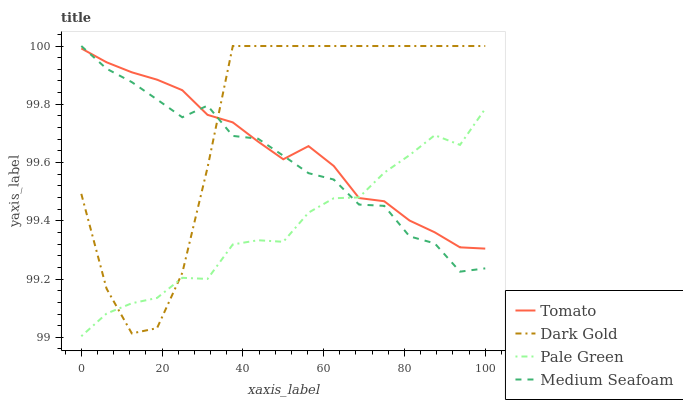Does Pale Green have the minimum area under the curve?
Answer yes or no. Yes. Does Dark Gold have the maximum area under the curve?
Answer yes or no. Yes. Does Medium Seafoam have the minimum area under the curve?
Answer yes or no. No. Does Medium Seafoam have the maximum area under the curve?
Answer yes or no. No. Is Tomato the smoothest?
Answer yes or no. Yes. Is Dark Gold the roughest?
Answer yes or no. Yes. Is Pale Green the smoothest?
Answer yes or no. No. Is Pale Green the roughest?
Answer yes or no. No. Does Pale Green have the lowest value?
Answer yes or no. Yes. Does Medium Seafoam have the lowest value?
Answer yes or no. No. Does Dark Gold have the highest value?
Answer yes or no. Yes. Does Pale Green have the highest value?
Answer yes or no. No. Does Pale Green intersect Tomato?
Answer yes or no. Yes. Is Pale Green less than Tomato?
Answer yes or no. No. Is Pale Green greater than Tomato?
Answer yes or no. No. 